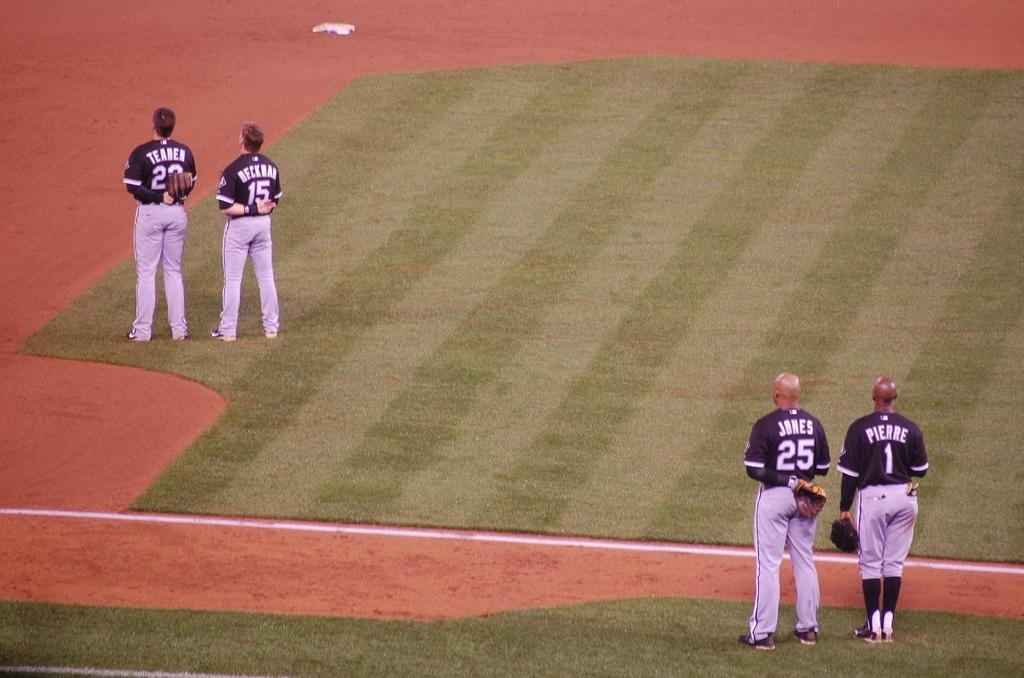Provide a one-sentence caption for the provided image. Teahen, Beckham, Jones, and Pierre are the baseball players standing for the anthem at the field. 